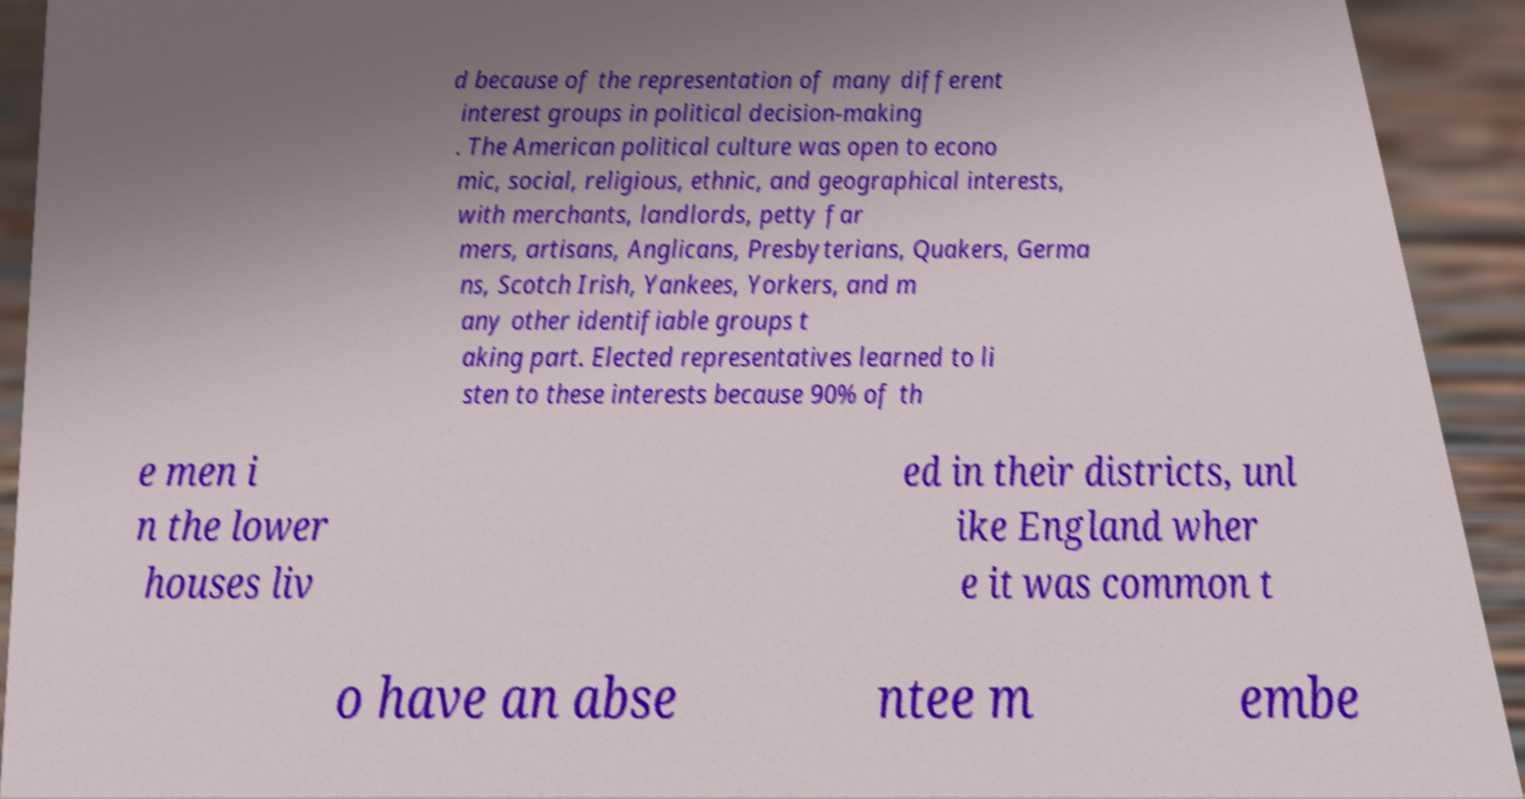There's text embedded in this image that I need extracted. Can you transcribe it verbatim? d because of the representation of many different interest groups in political decision-making . The American political culture was open to econo mic, social, religious, ethnic, and geographical interests, with merchants, landlords, petty far mers, artisans, Anglicans, Presbyterians, Quakers, Germa ns, Scotch Irish, Yankees, Yorkers, and m any other identifiable groups t aking part. Elected representatives learned to li sten to these interests because 90% of th e men i n the lower houses liv ed in their districts, unl ike England wher e it was common t o have an abse ntee m embe 